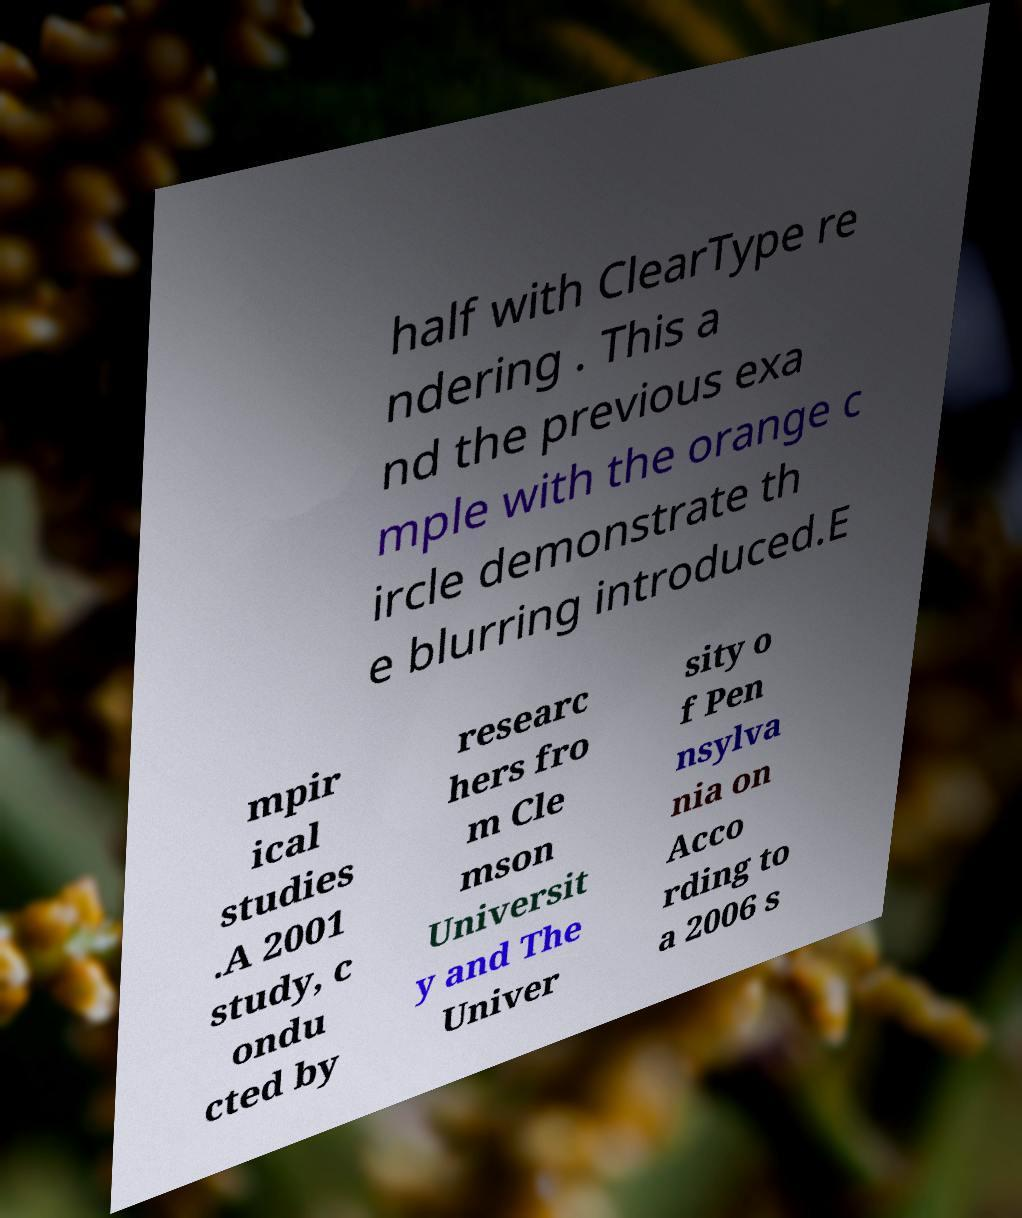I need the written content from this picture converted into text. Can you do that? half with ClearType re ndering . This a nd the previous exa mple with the orange c ircle demonstrate th e blurring introduced.E mpir ical studies .A 2001 study, c ondu cted by researc hers fro m Cle mson Universit y and The Univer sity o f Pen nsylva nia on Acco rding to a 2006 s 